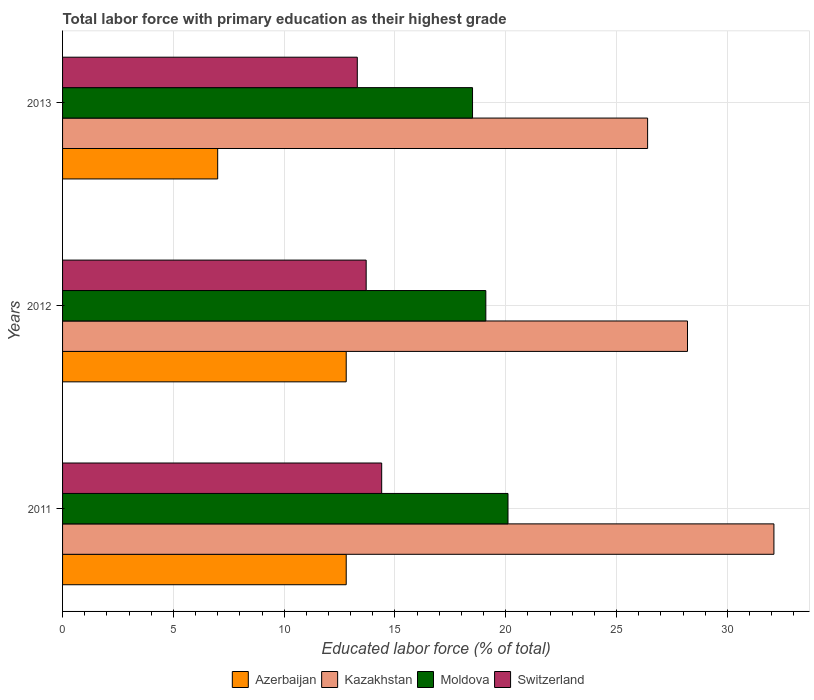How many different coloured bars are there?
Offer a very short reply. 4. Are the number of bars per tick equal to the number of legend labels?
Provide a succinct answer. Yes. Are the number of bars on each tick of the Y-axis equal?
Provide a succinct answer. Yes. In how many cases, is the number of bars for a given year not equal to the number of legend labels?
Provide a short and direct response. 0. What is the percentage of total labor force with primary education in Kazakhstan in 2013?
Make the answer very short. 26.4. Across all years, what is the maximum percentage of total labor force with primary education in Moldova?
Ensure brevity in your answer.  20.1. Across all years, what is the minimum percentage of total labor force with primary education in Switzerland?
Your answer should be compact. 13.3. In which year was the percentage of total labor force with primary education in Switzerland minimum?
Your response must be concise. 2013. What is the total percentage of total labor force with primary education in Switzerland in the graph?
Your answer should be very brief. 41.4. What is the difference between the percentage of total labor force with primary education in Kazakhstan in 2012 and that in 2013?
Make the answer very short. 1.8. What is the difference between the percentage of total labor force with primary education in Switzerland in 2011 and the percentage of total labor force with primary education in Moldova in 2012?
Give a very brief answer. -4.7. What is the average percentage of total labor force with primary education in Switzerland per year?
Your answer should be compact. 13.8. In the year 2012, what is the difference between the percentage of total labor force with primary education in Kazakhstan and percentage of total labor force with primary education in Moldova?
Your answer should be compact. 9.1. What is the ratio of the percentage of total labor force with primary education in Switzerland in 2011 to that in 2012?
Ensure brevity in your answer.  1.05. Is the difference between the percentage of total labor force with primary education in Kazakhstan in 2012 and 2013 greater than the difference between the percentage of total labor force with primary education in Moldova in 2012 and 2013?
Make the answer very short. Yes. What is the difference between the highest and the second highest percentage of total labor force with primary education in Switzerland?
Your response must be concise. 0.7. What is the difference between the highest and the lowest percentage of total labor force with primary education in Kazakhstan?
Offer a very short reply. 5.7. In how many years, is the percentage of total labor force with primary education in Moldova greater than the average percentage of total labor force with primary education in Moldova taken over all years?
Provide a short and direct response. 1. Is the sum of the percentage of total labor force with primary education in Kazakhstan in 2012 and 2013 greater than the maximum percentage of total labor force with primary education in Switzerland across all years?
Offer a terse response. Yes. Is it the case that in every year, the sum of the percentage of total labor force with primary education in Switzerland and percentage of total labor force with primary education in Azerbaijan is greater than the sum of percentage of total labor force with primary education in Moldova and percentage of total labor force with primary education in Kazakhstan?
Keep it short and to the point. No. What does the 2nd bar from the top in 2011 represents?
Your response must be concise. Moldova. What does the 3rd bar from the bottom in 2013 represents?
Provide a succinct answer. Moldova. Are the values on the major ticks of X-axis written in scientific E-notation?
Your response must be concise. No. Where does the legend appear in the graph?
Your answer should be compact. Bottom center. How many legend labels are there?
Provide a succinct answer. 4. What is the title of the graph?
Your answer should be compact. Total labor force with primary education as their highest grade. What is the label or title of the X-axis?
Ensure brevity in your answer.  Educated labor force (% of total). What is the Educated labor force (% of total) of Azerbaijan in 2011?
Ensure brevity in your answer.  12.8. What is the Educated labor force (% of total) of Kazakhstan in 2011?
Your answer should be very brief. 32.1. What is the Educated labor force (% of total) of Moldova in 2011?
Offer a terse response. 20.1. What is the Educated labor force (% of total) of Switzerland in 2011?
Provide a succinct answer. 14.4. What is the Educated labor force (% of total) in Azerbaijan in 2012?
Provide a short and direct response. 12.8. What is the Educated labor force (% of total) in Kazakhstan in 2012?
Provide a succinct answer. 28.2. What is the Educated labor force (% of total) in Moldova in 2012?
Provide a short and direct response. 19.1. What is the Educated labor force (% of total) in Switzerland in 2012?
Provide a succinct answer. 13.7. What is the Educated labor force (% of total) of Azerbaijan in 2013?
Make the answer very short. 7. What is the Educated labor force (% of total) of Kazakhstan in 2013?
Your response must be concise. 26.4. What is the Educated labor force (% of total) of Switzerland in 2013?
Offer a very short reply. 13.3. Across all years, what is the maximum Educated labor force (% of total) of Azerbaijan?
Provide a short and direct response. 12.8. Across all years, what is the maximum Educated labor force (% of total) in Kazakhstan?
Your response must be concise. 32.1. Across all years, what is the maximum Educated labor force (% of total) in Moldova?
Provide a succinct answer. 20.1. Across all years, what is the maximum Educated labor force (% of total) in Switzerland?
Give a very brief answer. 14.4. Across all years, what is the minimum Educated labor force (% of total) in Azerbaijan?
Keep it short and to the point. 7. Across all years, what is the minimum Educated labor force (% of total) of Kazakhstan?
Offer a terse response. 26.4. Across all years, what is the minimum Educated labor force (% of total) in Moldova?
Provide a succinct answer. 18.5. Across all years, what is the minimum Educated labor force (% of total) in Switzerland?
Provide a succinct answer. 13.3. What is the total Educated labor force (% of total) of Azerbaijan in the graph?
Your response must be concise. 32.6. What is the total Educated labor force (% of total) of Kazakhstan in the graph?
Ensure brevity in your answer.  86.7. What is the total Educated labor force (% of total) in Moldova in the graph?
Provide a succinct answer. 57.7. What is the total Educated labor force (% of total) of Switzerland in the graph?
Keep it short and to the point. 41.4. What is the difference between the Educated labor force (% of total) in Azerbaijan in 2011 and that in 2012?
Offer a terse response. 0. What is the difference between the Educated labor force (% of total) of Kazakhstan in 2011 and that in 2012?
Offer a terse response. 3.9. What is the difference between the Educated labor force (% of total) of Azerbaijan in 2011 and that in 2013?
Your answer should be compact. 5.8. What is the difference between the Educated labor force (% of total) of Kazakhstan in 2011 and that in 2013?
Give a very brief answer. 5.7. What is the difference between the Educated labor force (% of total) of Moldova in 2011 and that in 2013?
Keep it short and to the point. 1.6. What is the difference between the Educated labor force (% of total) in Switzerland in 2011 and that in 2013?
Give a very brief answer. 1.1. What is the difference between the Educated labor force (% of total) in Kazakhstan in 2012 and that in 2013?
Offer a terse response. 1.8. What is the difference between the Educated labor force (% of total) of Switzerland in 2012 and that in 2013?
Provide a succinct answer. 0.4. What is the difference between the Educated labor force (% of total) in Azerbaijan in 2011 and the Educated labor force (% of total) in Kazakhstan in 2012?
Your answer should be compact. -15.4. What is the difference between the Educated labor force (% of total) of Azerbaijan in 2011 and the Educated labor force (% of total) of Switzerland in 2012?
Keep it short and to the point. -0.9. What is the difference between the Educated labor force (% of total) of Kazakhstan in 2011 and the Educated labor force (% of total) of Moldova in 2012?
Your response must be concise. 13. What is the difference between the Educated labor force (% of total) of Moldova in 2011 and the Educated labor force (% of total) of Switzerland in 2012?
Provide a succinct answer. 6.4. What is the difference between the Educated labor force (% of total) of Azerbaijan in 2011 and the Educated labor force (% of total) of Moldova in 2013?
Your response must be concise. -5.7. What is the difference between the Educated labor force (% of total) of Azerbaijan in 2011 and the Educated labor force (% of total) of Switzerland in 2013?
Offer a very short reply. -0.5. What is the difference between the Educated labor force (% of total) of Kazakhstan in 2011 and the Educated labor force (% of total) of Switzerland in 2013?
Provide a succinct answer. 18.8. What is the difference between the Educated labor force (% of total) in Azerbaijan in 2012 and the Educated labor force (% of total) in Kazakhstan in 2013?
Your response must be concise. -13.6. What is the difference between the Educated labor force (% of total) of Azerbaijan in 2012 and the Educated labor force (% of total) of Switzerland in 2013?
Provide a succinct answer. -0.5. What is the difference between the Educated labor force (% of total) in Moldova in 2012 and the Educated labor force (% of total) in Switzerland in 2013?
Offer a terse response. 5.8. What is the average Educated labor force (% of total) in Azerbaijan per year?
Offer a very short reply. 10.87. What is the average Educated labor force (% of total) in Kazakhstan per year?
Provide a short and direct response. 28.9. What is the average Educated labor force (% of total) of Moldova per year?
Give a very brief answer. 19.23. What is the average Educated labor force (% of total) in Switzerland per year?
Offer a very short reply. 13.8. In the year 2011, what is the difference between the Educated labor force (% of total) of Azerbaijan and Educated labor force (% of total) of Kazakhstan?
Give a very brief answer. -19.3. In the year 2011, what is the difference between the Educated labor force (% of total) in Azerbaijan and Educated labor force (% of total) in Moldova?
Provide a short and direct response. -7.3. In the year 2011, what is the difference between the Educated labor force (% of total) of Azerbaijan and Educated labor force (% of total) of Switzerland?
Keep it short and to the point. -1.6. In the year 2011, what is the difference between the Educated labor force (% of total) of Kazakhstan and Educated labor force (% of total) of Moldova?
Your response must be concise. 12. In the year 2011, what is the difference between the Educated labor force (% of total) in Moldova and Educated labor force (% of total) in Switzerland?
Provide a short and direct response. 5.7. In the year 2012, what is the difference between the Educated labor force (% of total) of Azerbaijan and Educated labor force (% of total) of Kazakhstan?
Your answer should be very brief. -15.4. In the year 2012, what is the difference between the Educated labor force (% of total) in Azerbaijan and Educated labor force (% of total) in Switzerland?
Ensure brevity in your answer.  -0.9. In the year 2012, what is the difference between the Educated labor force (% of total) in Moldova and Educated labor force (% of total) in Switzerland?
Offer a very short reply. 5.4. In the year 2013, what is the difference between the Educated labor force (% of total) in Azerbaijan and Educated labor force (% of total) in Kazakhstan?
Give a very brief answer. -19.4. In the year 2013, what is the difference between the Educated labor force (% of total) of Azerbaijan and Educated labor force (% of total) of Moldova?
Your answer should be compact. -11.5. In the year 2013, what is the difference between the Educated labor force (% of total) in Azerbaijan and Educated labor force (% of total) in Switzerland?
Your answer should be very brief. -6.3. In the year 2013, what is the difference between the Educated labor force (% of total) of Kazakhstan and Educated labor force (% of total) of Moldova?
Give a very brief answer. 7.9. In the year 2013, what is the difference between the Educated labor force (% of total) in Kazakhstan and Educated labor force (% of total) in Switzerland?
Give a very brief answer. 13.1. In the year 2013, what is the difference between the Educated labor force (% of total) in Moldova and Educated labor force (% of total) in Switzerland?
Offer a very short reply. 5.2. What is the ratio of the Educated labor force (% of total) of Azerbaijan in 2011 to that in 2012?
Provide a short and direct response. 1. What is the ratio of the Educated labor force (% of total) in Kazakhstan in 2011 to that in 2012?
Give a very brief answer. 1.14. What is the ratio of the Educated labor force (% of total) in Moldova in 2011 to that in 2012?
Offer a very short reply. 1.05. What is the ratio of the Educated labor force (% of total) in Switzerland in 2011 to that in 2012?
Give a very brief answer. 1.05. What is the ratio of the Educated labor force (% of total) in Azerbaijan in 2011 to that in 2013?
Your answer should be very brief. 1.83. What is the ratio of the Educated labor force (% of total) in Kazakhstan in 2011 to that in 2013?
Ensure brevity in your answer.  1.22. What is the ratio of the Educated labor force (% of total) of Moldova in 2011 to that in 2013?
Provide a short and direct response. 1.09. What is the ratio of the Educated labor force (% of total) in Switzerland in 2011 to that in 2013?
Give a very brief answer. 1.08. What is the ratio of the Educated labor force (% of total) of Azerbaijan in 2012 to that in 2013?
Provide a short and direct response. 1.83. What is the ratio of the Educated labor force (% of total) in Kazakhstan in 2012 to that in 2013?
Provide a succinct answer. 1.07. What is the ratio of the Educated labor force (% of total) of Moldova in 2012 to that in 2013?
Your answer should be very brief. 1.03. What is the ratio of the Educated labor force (% of total) of Switzerland in 2012 to that in 2013?
Keep it short and to the point. 1.03. What is the difference between the highest and the second highest Educated labor force (% of total) in Moldova?
Offer a terse response. 1. What is the difference between the highest and the lowest Educated labor force (% of total) of Moldova?
Your answer should be very brief. 1.6. 